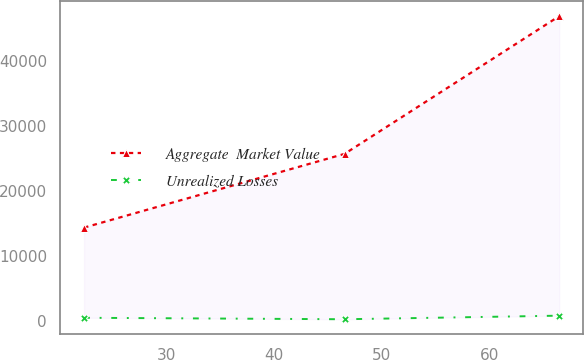Convert chart to OTSL. <chart><loc_0><loc_0><loc_500><loc_500><line_chart><ecel><fcel>Aggregate  Market Value<fcel>Unrealized Losses<nl><fcel>22.34<fcel>14350.4<fcel>457.81<nl><fcel>46.56<fcel>25709.9<fcel>231.11<nl><fcel>66.52<fcel>46931.3<fcel>783.64<nl></chart> 